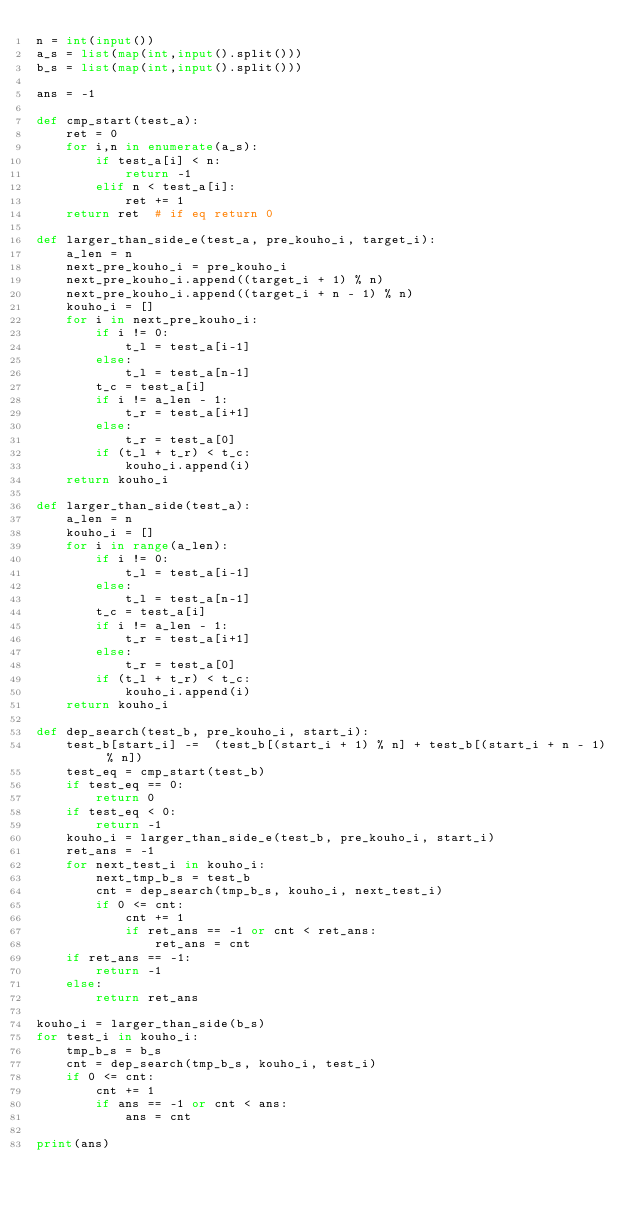<code> <loc_0><loc_0><loc_500><loc_500><_Python_>n = int(input())
a_s = list(map(int,input().split()))
b_s = list(map(int,input().split()))

ans = -1

def cmp_start(test_a):
    ret = 0
    for i,n in enumerate(a_s):
        if test_a[i] < n:
            return -1
        elif n < test_a[i]:
            ret += 1
    return ret  # if eq return 0

def larger_than_side_e(test_a, pre_kouho_i, target_i):
    a_len = n
    next_pre_kouho_i = pre_kouho_i
    next_pre_kouho_i.append((target_i + 1) % n)
    next_pre_kouho_i.append((target_i + n - 1) % n)
    kouho_i = []
    for i in next_pre_kouho_i:
        if i != 0:
            t_l = test_a[i-1]
        else:
            t_l = test_a[n-1]    
        t_c = test_a[i]
        if i != a_len - 1:
            t_r = test_a[i+1]
        else:
            t_r = test_a[0]
        if (t_l + t_r) < t_c:
            kouho_i.append(i)   
    return kouho_i

def larger_than_side(test_a):
    a_len = n
    kouho_i = []
    for i in range(a_len):
        if i != 0:
            t_l = test_a[i-1]
        else:
            t_l = test_a[n-1]    
        t_c = test_a[i]
        if i != a_len - 1:
            t_r = test_a[i+1]
        else:
            t_r = test_a[0]
        if (t_l + t_r) < t_c:
            kouho_i.append(i)   
    return kouho_i

def dep_search(test_b, pre_kouho_i, start_i):
    test_b[start_i] -=  (test_b[(start_i + 1) % n] + test_b[(start_i + n - 1) % n])
    test_eq = cmp_start(test_b)
    if test_eq == 0:
        return 0
    if test_eq < 0:
        return -1
    kouho_i = larger_than_side_e(test_b, pre_kouho_i, start_i)
    ret_ans = -1
    for next_test_i in kouho_i:
        next_tmp_b_s = test_b
        cnt = dep_search(tmp_b_s, kouho_i, next_test_i)
        if 0 <= cnt:
            cnt += 1
            if ret_ans == -1 or cnt < ret_ans:
                ret_ans = cnt
    if ret_ans == -1:
        return -1
    else:
        return ret_ans

kouho_i = larger_than_side(b_s)
for test_i in kouho_i:
    tmp_b_s = b_s
    cnt = dep_search(tmp_b_s, kouho_i, test_i)
    if 0 <= cnt:
        cnt += 1
        if ans == -1 or cnt < ans:
            ans = cnt

print(ans)</code> 